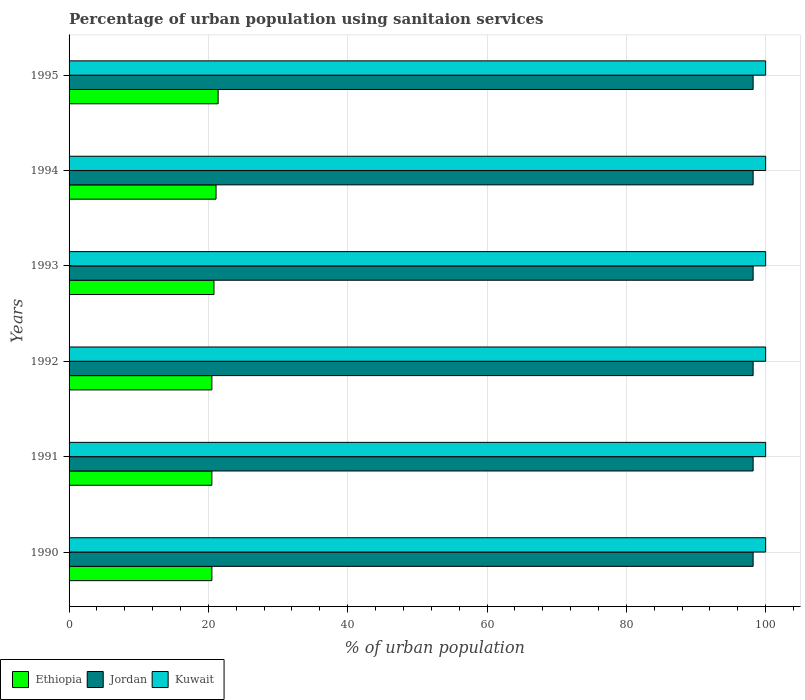How many different coloured bars are there?
Make the answer very short. 3. Are the number of bars per tick equal to the number of legend labels?
Keep it short and to the point. Yes. Are the number of bars on each tick of the Y-axis equal?
Your answer should be compact. Yes. How many bars are there on the 5th tick from the top?
Offer a terse response. 3. In how many cases, is the number of bars for a given year not equal to the number of legend labels?
Provide a succinct answer. 0. What is the percentage of urban population using sanitaion services in Ethiopia in 1992?
Make the answer very short. 20.5. Across all years, what is the maximum percentage of urban population using sanitaion services in Kuwait?
Keep it short and to the point. 100. Across all years, what is the minimum percentage of urban population using sanitaion services in Kuwait?
Your response must be concise. 100. In which year was the percentage of urban population using sanitaion services in Ethiopia maximum?
Your answer should be compact. 1995. In which year was the percentage of urban population using sanitaion services in Jordan minimum?
Keep it short and to the point. 1990. What is the total percentage of urban population using sanitaion services in Jordan in the graph?
Provide a short and direct response. 589.2. What is the difference between the percentage of urban population using sanitaion services in Kuwait in 1990 and that in 1992?
Your answer should be very brief. 0. What is the difference between the percentage of urban population using sanitaion services in Jordan in 1993 and the percentage of urban population using sanitaion services in Kuwait in 1995?
Provide a short and direct response. -1.8. What is the average percentage of urban population using sanitaion services in Jordan per year?
Offer a very short reply. 98.2. In the year 1990, what is the difference between the percentage of urban population using sanitaion services in Ethiopia and percentage of urban population using sanitaion services in Jordan?
Provide a short and direct response. -77.7. In how many years, is the percentage of urban population using sanitaion services in Kuwait greater than 72 %?
Your response must be concise. 6. What is the ratio of the percentage of urban population using sanitaion services in Kuwait in 1991 to that in 1995?
Give a very brief answer. 1. Is the difference between the percentage of urban population using sanitaion services in Ethiopia in 1991 and 1993 greater than the difference between the percentage of urban population using sanitaion services in Jordan in 1991 and 1993?
Make the answer very short. No. What is the difference between the highest and the lowest percentage of urban population using sanitaion services in Jordan?
Make the answer very short. 0. In how many years, is the percentage of urban population using sanitaion services in Ethiopia greater than the average percentage of urban population using sanitaion services in Ethiopia taken over all years?
Your response must be concise. 2. Is the sum of the percentage of urban population using sanitaion services in Kuwait in 1991 and 1992 greater than the maximum percentage of urban population using sanitaion services in Ethiopia across all years?
Provide a short and direct response. Yes. What does the 2nd bar from the top in 1990 represents?
Offer a terse response. Jordan. What does the 1st bar from the bottom in 1991 represents?
Keep it short and to the point. Ethiopia. How many bars are there?
Your answer should be very brief. 18. How many years are there in the graph?
Your response must be concise. 6. Are the values on the major ticks of X-axis written in scientific E-notation?
Keep it short and to the point. No. Does the graph contain any zero values?
Make the answer very short. No. Does the graph contain grids?
Offer a very short reply. Yes. Where does the legend appear in the graph?
Keep it short and to the point. Bottom left. How are the legend labels stacked?
Keep it short and to the point. Horizontal. What is the title of the graph?
Your response must be concise. Percentage of urban population using sanitaion services. What is the label or title of the X-axis?
Give a very brief answer. % of urban population. What is the label or title of the Y-axis?
Provide a succinct answer. Years. What is the % of urban population of Ethiopia in 1990?
Ensure brevity in your answer.  20.5. What is the % of urban population of Jordan in 1990?
Offer a terse response. 98.2. What is the % of urban population of Ethiopia in 1991?
Provide a succinct answer. 20.5. What is the % of urban population in Jordan in 1991?
Offer a terse response. 98.2. What is the % of urban population of Ethiopia in 1992?
Make the answer very short. 20.5. What is the % of urban population of Jordan in 1992?
Make the answer very short. 98.2. What is the % of urban population of Kuwait in 1992?
Offer a terse response. 100. What is the % of urban population in Ethiopia in 1993?
Your answer should be very brief. 20.8. What is the % of urban population in Jordan in 1993?
Offer a very short reply. 98.2. What is the % of urban population in Ethiopia in 1994?
Provide a succinct answer. 21.1. What is the % of urban population of Jordan in 1994?
Offer a very short reply. 98.2. What is the % of urban population of Ethiopia in 1995?
Keep it short and to the point. 21.4. What is the % of urban population of Jordan in 1995?
Make the answer very short. 98.2. What is the % of urban population in Kuwait in 1995?
Provide a succinct answer. 100. Across all years, what is the maximum % of urban population in Ethiopia?
Your response must be concise. 21.4. Across all years, what is the maximum % of urban population of Jordan?
Offer a very short reply. 98.2. Across all years, what is the maximum % of urban population of Kuwait?
Keep it short and to the point. 100. Across all years, what is the minimum % of urban population of Jordan?
Provide a short and direct response. 98.2. What is the total % of urban population in Ethiopia in the graph?
Your answer should be compact. 124.8. What is the total % of urban population in Jordan in the graph?
Give a very brief answer. 589.2. What is the total % of urban population in Kuwait in the graph?
Offer a very short reply. 600. What is the difference between the % of urban population of Ethiopia in 1990 and that in 1991?
Give a very brief answer. 0. What is the difference between the % of urban population in Ethiopia in 1990 and that in 1992?
Provide a succinct answer. 0. What is the difference between the % of urban population in Jordan in 1990 and that in 1992?
Offer a very short reply. 0. What is the difference between the % of urban population of Kuwait in 1990 and that in 1992?
Make the answer very short. 0. What is the difference between the % of urban population of Ethiopia in 1990 and that in 1993?
Provide a succinct answer. -0.3. What is the difference between the % of urban population in Ethiopia in 1990 and that in 1994?
Provide a succinct answer. -0.6. What is the difference between the % of urban population in Kuwait in 1990 and that in 1994?
Your response must be concise. 0. What is the difference between the % of urban population in Kuwait in 1990 and that in 1995?
Your response must be concise. 0. What is the difference between the % of urban population in Ethiopia in 1991 and that in 1992?
Offer a terse response. 0. What is the difference between the % of urban population of Kuwait in 1991 and that in 1992?
Your response must be concise. 0. What is the difference between the % of urban population in Jordan in 1991 and that in 1993?
Ensure brevity in your answer.  0. What is the difference between the % of urban population in Kuwait in 1991 and that in 1993?
Keep it short and to the point. 0. What is the difference between the % of urban population of Kuwait in 1991 and that in 1994?
Your answer should be very brief. 0. What is the difference between the % of urban population in Ethiopia in 1992 and that in 1993?
Offer a terse response. -0.3. What is the difference between the % of urban population of Kuwait in 1992 and that in 1993?
Keep it short and to the point. 0. What is the difference between the % of urban population of Ethiopia in 1992 and that in 1994?
Make the answer very short. -0.6. What is the difference between the % of urban population in Jordan in 1992 and that in 1994?
Offer a terse response. 0. What is the difference between the % of urban population in Kuwait in 1992 and that in 1994?
Ensure brevity in your answer.  0. What is the difference between the % of urban population in Ethiopia in 1993 and that in 1994?
Give a very brief answer. -0.3. What is the difference between the % of urban population of Ethiopia in 1993 and that in 1995?
Provide a short and direct response. -0.6. What is the difference between the % of urban population of Jordan in 1993 and that in 1995?
Your answer should be very brief. 0. What is the difference between the % of urban population in Kuwait in 1993 and that in 1995?
Give a very brief answer. 0. What is the difference between the % of urban population in Ethiopia in 1994 and that in 1995?
Provide a short and direct response. -0.3. What is the difference between the % of urban population in Ethiopia in 1990 and the % of urban population in Jordan in 1991?
Offer a terse response. -77.7. What is the difference between the % of urban population of Ethiopia in 1990 and the % of urban population of Kuwait in 1991?
Your answer should be very brief. -79.5. What is the difference between the % of urban population of Jordan in 1990 and the % of urban population of Kuwait in 1991?
Offer a very short reply. -1.8. What is the difference between the % of urban population of Ethiopia in 1990 and the % of urban population of Jordan in 1992?
Your response must be concise. -77.7. What is the difference between the % of urban population of Ethiopia in 1990 and the % of urban population of Kuwait in 1992?
Give a very brief answer. -79.5. What is the difference between the % of urban population of Ethiopia in 1990 and the % of urban population of Jordan in 1993?
Make the answer very short. -77.7. What is the difference between the % of urban population in Ethiopia in 1990 and the % of urban population in Kuwait in 1993?
Your answer should be very brief. -79.5. What is the difference between the % of urban population of Ethiopia in 1990 and the % of urban population of Jordan in 1994?
Your answer should be compact. -77.7. What is the difference between the % of urban population of Ethiopia in 1990 and the % of urban population of Kuwait in 1994?
Give a very brief answer. -79.5. What is the difference between the % of urban population of Ethiopia in 1990 and the % of urban population of Jordan in 1995?
Make the answer very short. -77.7. What is the difference between the % of urban population in Ethiopia in 1990 and the % of urban population in Kuwait in 1995?
Ensure brevity in your answer.  -79.5. What is the difference between the % of urban population in Jordan in 1990 and the % of urban population in Kuwait in 1995?
Provide a short and direct response. -1.8. What is the difference between the % of urban population of Ethiopia in 1991 and the % of urban population of Jordan in 1992?
Provide a succinct answer. -77.7. What is the difference between the % of urban population in Ethiopia in 1991 and the % of urban population in Kuwait in 1992?
Provide a succinct answer. -79.5. What is the difference between the % of urban population in Ethiopia in 1991 and the % of urban population in Jordan in 1993?
Provide a short and direct response. -77.7. What is the difference between the % of urban population of Ethiopia in 1991 and the % of urban population of Kuwait in 1993?
Ensure brevity in your answer.  -79.5. What is the difference between the % of urban population in Ethiopia in 1991 and the % of urban population in Jordan in 1994?
Make the answer very short. -77.7. What is the difference between the % of urban population of Ethiopia in 1991 and the % of urban population of Kuwait in 1994?
Your answer should be very brief. -79.5. What is the difference between the % of urban population in Jordan in 1991 and the % of urban population in Kuwait in 1994?
Your response must be concise. -1.8. What is the difference between the % of urban population of Ethiopia in 1991 and the % of urban population of Jordan in 1995?
Provide a short and direct response. -77.7. What is the difference between the % of urban population of Ethiopia in 1991 and the % of urban population of Kuwait in 1995?
Ensure brevity in your answer.  -79.5. What is the difference between the % of urban population in Jordan in 1991 and the % of urban population in Kuwait in 1995?
Your answer should be very brief. -1.8. What is the difference between the % of urban population in Ethiopia in 1992 and the % of urban population in Jordan in 1993?
Your response must be concise. -77.7. What is the difference between the % of urban population of Ethiopia in 1992 and the % of urban population of Kuwait in 1993?
Offer a terse response. -79.5. What is the difference between the % of urban population of Jordan in 1992 and the % of urban population of Kuwait in 1993?
Keep it short and to the point. -1.8. What is the difference between the % of urban population in Ethiopia in 1992 and the % of urban population in Jordan in 1994?
Provide a succinct answer. -77.7. What is the difference between the % of urban population of Ethiopia in 1992 and the % of urban population of Kuwait in 1994?
Offer a very short reply. -79.5. What is the difference between the % of urban population of Ethiopia in 1992 and the % of urban population of Jordan in 1995?
Your answer should be compact. -77.7. What is the difference between the % of urban population in Ethiopia in 1992 and the % of urban population in Kuwait in 1995?
Make the answer very short. -79.5. What is the difference between the % of urban population in Jordan in 1992 and the % of urban population in Kuwait in 1995?
Keep it short and to the point. -1.8. What is the difference between the % of urban population of Ethiopia in 1993 and the % of urban population of Jordan in 1994?
Provide a short and direct response. -77.4. What is the difference between the % of urban population in Ethiopia in 1993 and the % of urban population in Kuwait in 1994?
Make the answer very short. -79.2. What is the difference between the % of urban population in Jordan in 1993 and the % of urban population in Kuwait in 1994?
Keep it short and to the point. -1.8. What is the difference between the % of urban population in Ethiopia in 1993 and the % of urban population in Jordan in 1995?
Offer a very short reply. -77.4. What is the difference between the % of urban population of Ethiopia in 1993 and the % of urban population of Kuwait in 1995?
Your answer should be very brief. -79.2. What is the difference between the % of urban population of Jordan in 1993 and the % of urban population of Kuwait in 1995?
Provide a short and direct response. -1.8. What is the difference between the % of urban population in Ethiopia in 1994 and the % of urban population in Jordan in 1995?
Offer a very short reply. -77.1. What is the difference between the % of urban population of Ethiopia in 1994 and the % of urban population of Kuwait in 1995?
Your response must be concise. -78.9. What is the difference between the % of urban population of Jordan in 1994 and the % of urban population of Kuwait in 1995?
Your answer should be very brief. -1.8. What is the average % of urban population of Ethiopia per year?
Keep it short and to the point. 20.8. What is the average % of urban population of Jordan per year?
Your response must be concise. 98.2. In the year 1990, what is the difference between the % of urban population in Ethiopia and % of urban population in Jordan?
Offer a very short reply. -77.7. In the year 1990, what is the difference between the % of urban population of Ethiopia and % of urban population of Kuwait?
Give a very brief answer. -79.5. In the year 1991, what is the difference between the % of urban population of Ethiopia and % of urban population of Jordan?
Your response must be concise. -77.7. In the year 1991, what is the difference between the % of urban population in Ethiopia and % of urban population in Kuwait?
Your answer should be compact. -79.5. In the year 1992, what is the difference between the % of urban population in Ethiopia and % of urban population in Jordan?
Keep it short and to the point. -77.7. In the year 1992, what is the difference between the % of urban population in Ethiopia and % of urban population in Kuwait?
Provide a succinct answer. -79.5. In the year 1993, what is the difference between the % of urban population in Ethiopia and % of urban population in Jordan?
Offer a terse response. -77.4. In the year 1993, what is the difference between the % of urban population of Ethiopia and % of urban population of Kuwait?
Keep it short and to the point. -79.2. In the year 1994, what is the difference between the % of urban population of Ethiopia and % of urban population of Jordan?
Provide a succinct answer. -77.1. In the year 1994, what is the difference between the % of urban population in Ethiopia and % of urban population in Kuwait?
Your answer should be very brief. -78.9. In the year 1994, what is the difference between the % of urban population in Jordan and % of urban population in Kuwait?
Give a very brief answer. -1.8. In the year 1995, what is the difference between the % of urban population of Ethiopia and % of urban population of Jordan?
Ensure brevity in your answer.  -76.8. In the year 1995, what is the difference between the % of urban population in Ethiopia and % of urban population in Kuwait?
Keep it short and to the point. -78.6. What is the ratio of the % of urban population of Kuwait in 1990 to that in 1991?
Your answer should be compact. 1. What is the ratio of the % of urban population in Ethiopia in 1990 to that in 1993?
Your response must be concise. 0.99. What is the ratio of the % of urban population in Ethiopia in 1990 to that in 1994?
Your response must be concise. 0.97. What is the ratio of the % of urban population in Ethiopia in 1990 to that in 1995?
Ensure brevity in your answer.  0.96. What is the ratio of the % of urban population in Ethiopia in 1991 to that in 1992?
Keep it short and to the point. 1. What is the ratio of the % of urban population of Jordan in 1991 to that in 1992?
Provide a succinct answer. 1. What is the ratio of the % of urban population of Kuwait in 1991 to that in 1992?
Offer a very short reply. 1. What is the ratio of the % of urban population in Ethiopia in 1991 to that in 1993?
Ensure brevity in your answer.  0.99. What is the ratio of the % of urban population in Kuwait in 1991 to that in 1993?
Make the answer very short. 1. What is the ratio of the % of urban population in Ethiopia in 1991 to that in 1994?
Offer a very short reply. 0.97. What is the ratio of the % of urban population of Jordan in 1991 to that in 1994?
Offer a very short reply. 1. What is the ratio of the % of urban population in Kuwait in 1991 to that in 1994?
Offer a terse response. 1. What is the ratio of the % of urban population in Ethiopia in 1991 to that in 1995?
Give a very brief answer. 0.96. What is the ratio of the % of urban population of Jordan in 1991 to that in 1995?
Provide a short and direct response. 1. What is the ratio of the % of urban population of Kuwait in 1991 to that in 1995?
Offer a very short reply. 1. What is the ratio of the % of urban population in Ethiopia in 1992 to that in 1993?
Give a very brief answer. 0.99. What is the ratio of the % of urban population in Ethiopia in 1992 to that in 1994?
Offer a terse response. 0.97. What is the ratio of the % of urban population in Jordan in 1992 to that in 1994?
Your response must be concise. 1. What is the ratio of the % of urban population in Ethiopia in 1992 to that in 1995?
Provide a succinct answer. 0.96. What is the ratio of the % of urban population in Kuwait in 1992 to that in 1995?
Provide a short and direct response. 1. What is the ratio of the % of urban population in Ethiopia in 1993 to that in 1994?
Give a very brief answer. 0.99. What is the ratio of the % of urban population in Ethiopia in 1993 to that in 1995?
Ensure brevity in your answer.  0.97. What is the ratio of the % of urban population of Jordan in 1993 to that in 1995?
Keep it short and to the point. 1. What is the ratio of the % of urban population of Jordan in 1994 to that in 1995?
Your response must be concise. 1. What is the difference between the highest and the lowest % of urban population in Jordan?
Offer a very short reply. 0. 